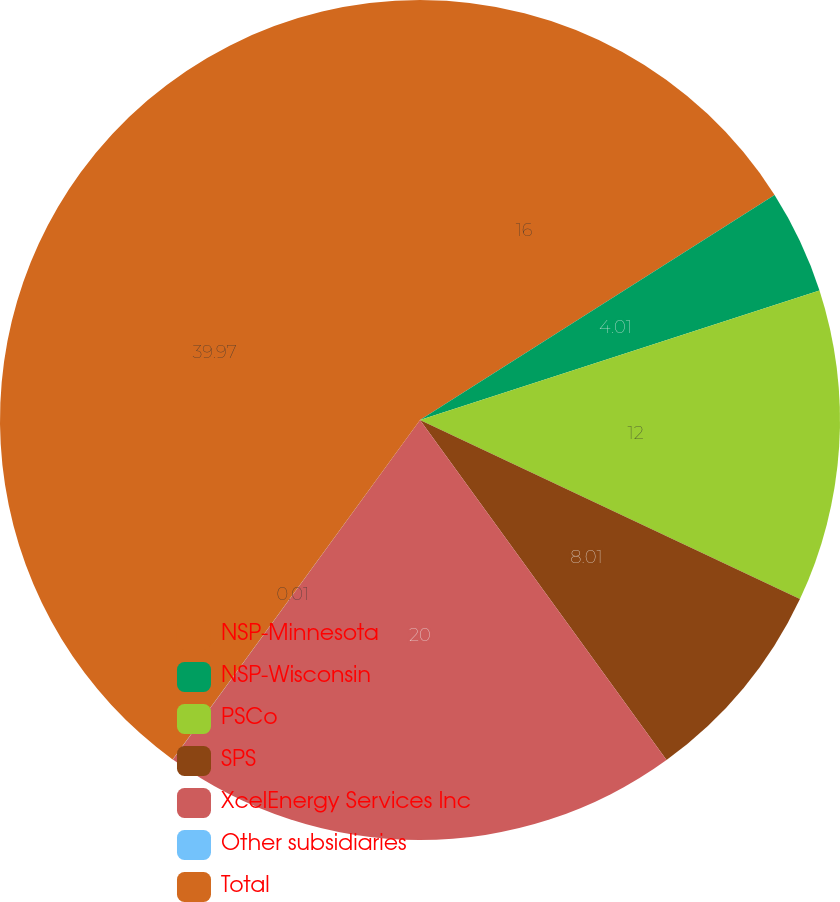<chart> <loc_0><loc_0><loc_500><loc_500><pie_chart><fcel>NSP-Minnesota<fcel>NSP-Wisconsin<fcel>PSCo<fcel>SPS<fcel>XcelEnergy Services Inc<fcel>Other subsidiaries<fcel>Total<nl><fcel>16.0%<fcel>4.01%<fcel>12.0%<fcel>8.01%<fcel>20.0%<fcel>0.01%<fcel>39.98%<nl></chart> 